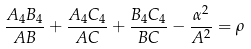<formula> <loc_0><loc_0><loc_500><loc_500>\frac { A _ { 4 } B _ { 4 } } { A B } + \frac { A _ { 4 } C _ { 4 } } { A C } + \frac { B _ { 4 } C _ { 4 } } { B C } - \frac { \alpha ^ { 2 } } { A ^ { 2 } } = \rho</formula> 